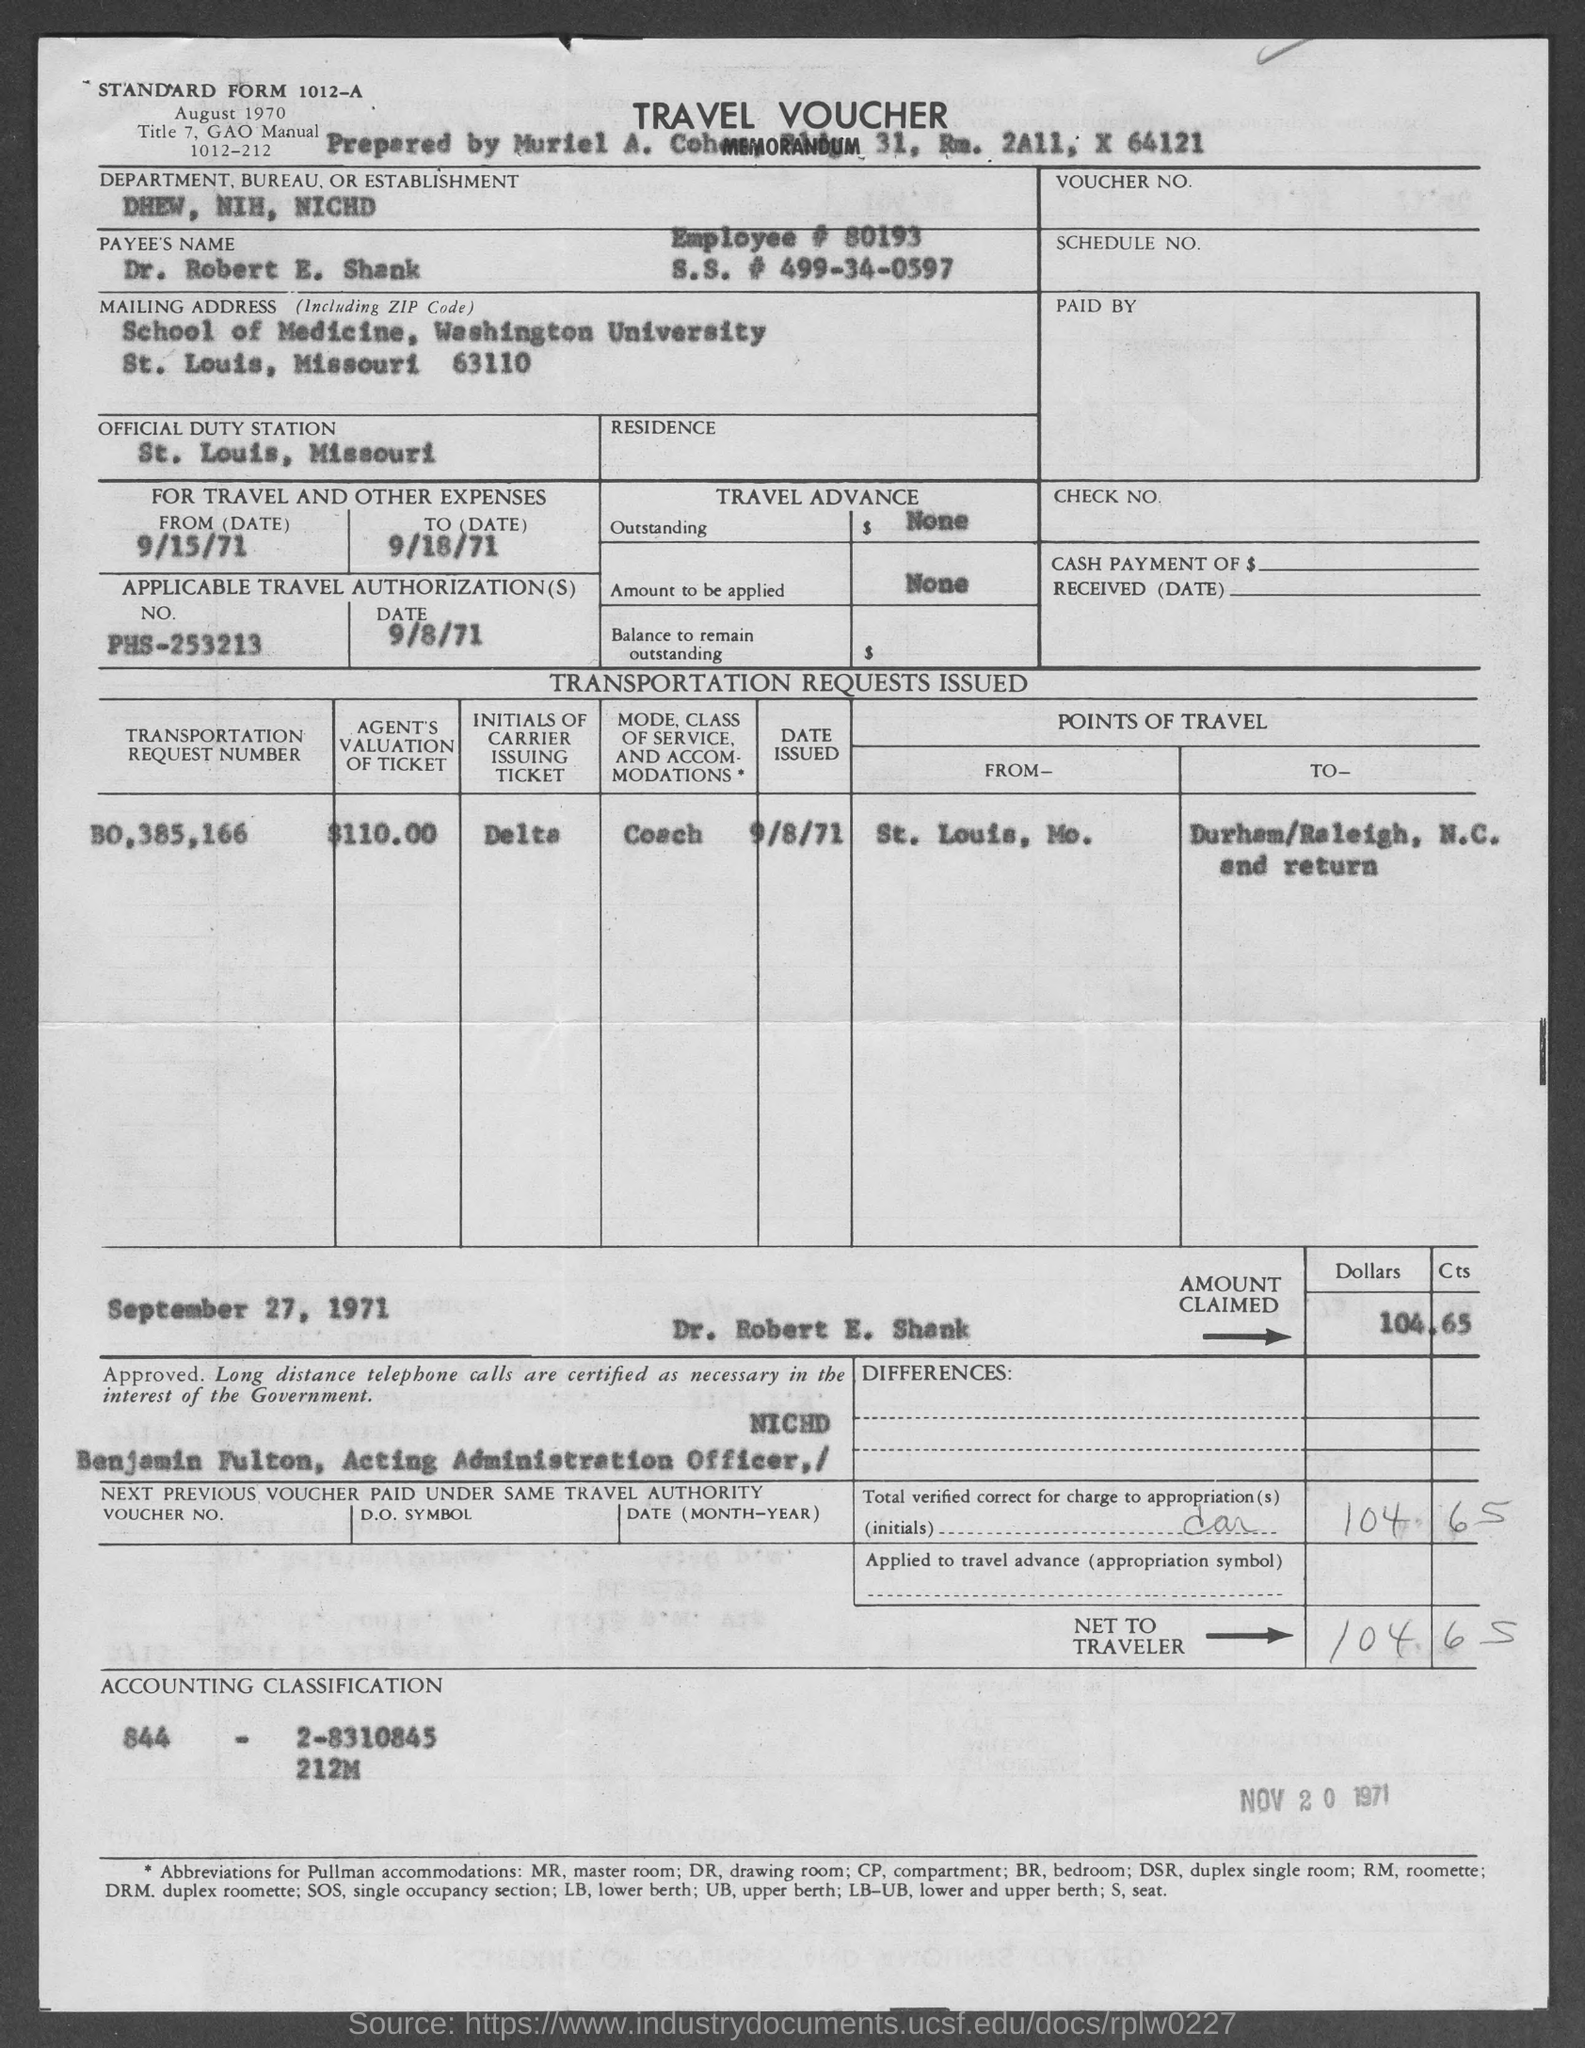Draw attention to some important aspects in this diagram. The voucher mentions the Department, Bureau, or Establishment as "DHEW, NIH, NICHD. In the voucher, the standard form number is 1012-A. Dr. Robert E. Shank's official duty station is St. Louis, Missouri. The applicable travel authorization date, as stated in the travel voucher, is 9/8/71. The employee number given in the voucher is 80193. 